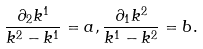Convert formula to latex. <formula><loc_0><loc_0><loc_500><loc_500>\frac { \partial _ { 2 } k ^ { 1 } } { k ^ { 2 } - k ^ { 1 } } = a , \frac { \partial _ { 1 } k ^ { 2 } } { k ^ { 1 } - k ^ { 2 } } = b .</formula> 